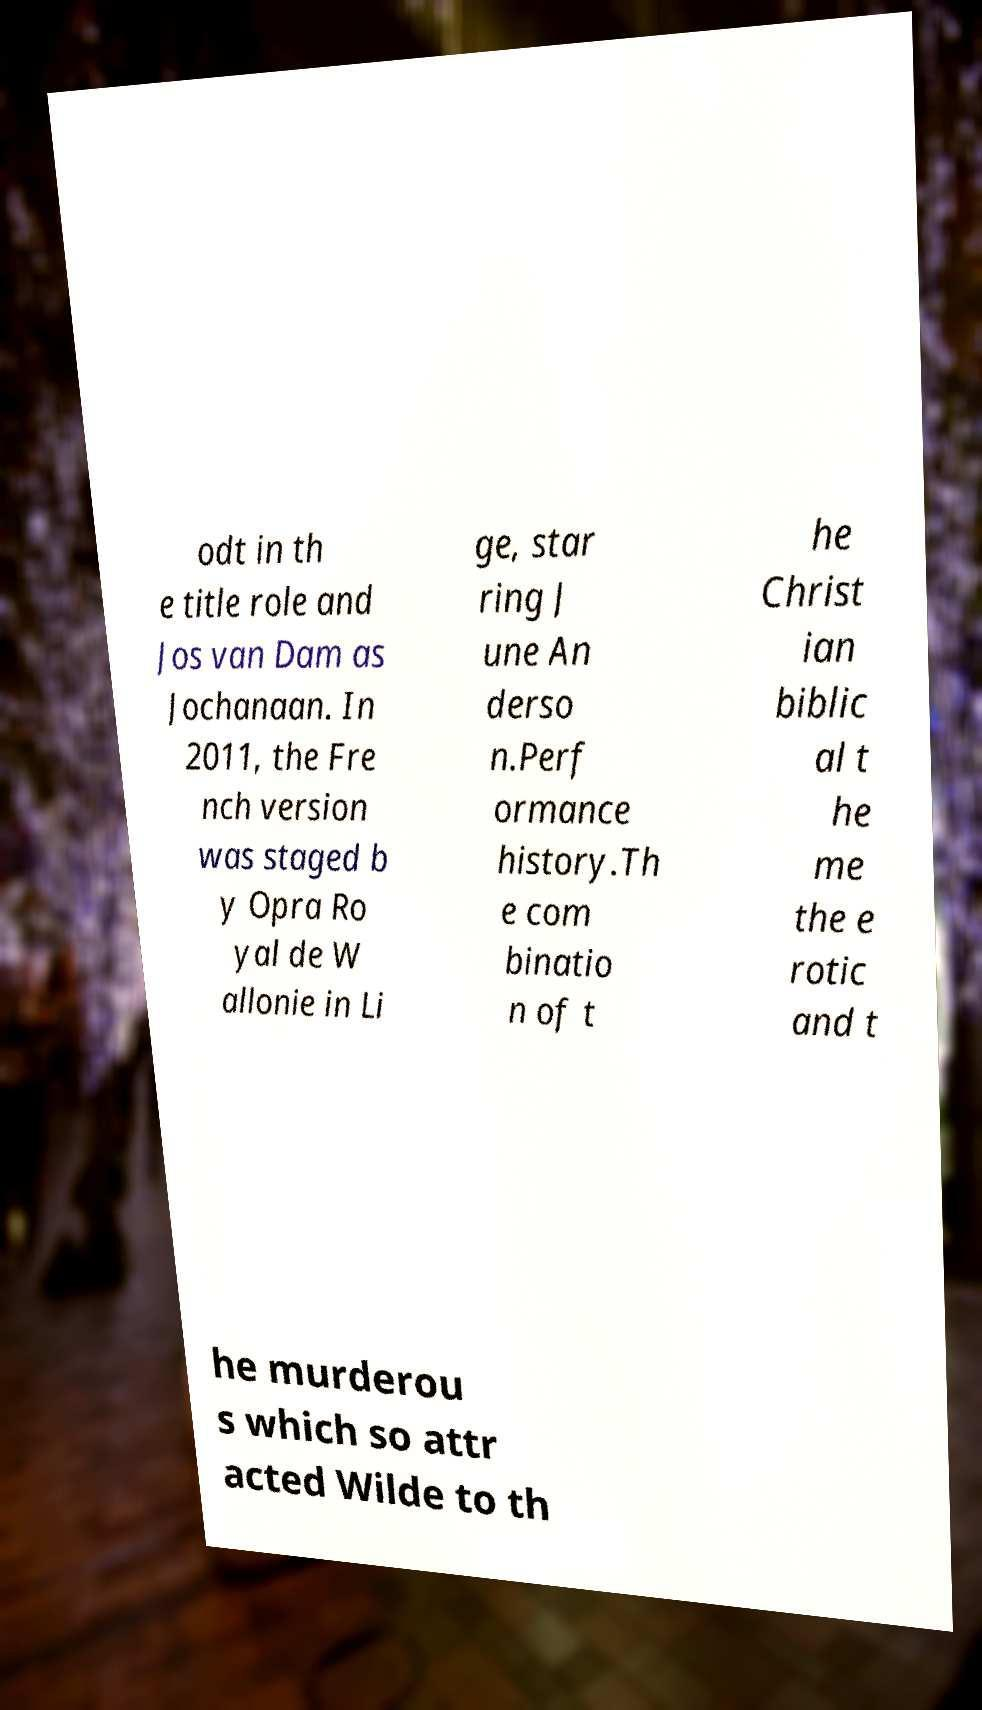Can you read and provide the text displayed in the image?This photo seems to have some interesting text. Can you extract and type it out for me? odt in th e title role and Jos van Dam as Jochanaan. In 2011, the Fre nch version was staged b y Opra Ro yal de W allonie in Li ge, star ring J une An derso n.Perf ormance history.Th e com binatio n of t he Christ ian biblic al t he me the e rotic and t he murderou s which so attr acted Wilde to th 